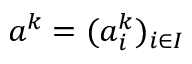<formula> <loc_0><loc_0><loc_500><loc_500>a ^ { k } = ( a _ { i } ^ { k } ) _ { i \in I }</formula> 